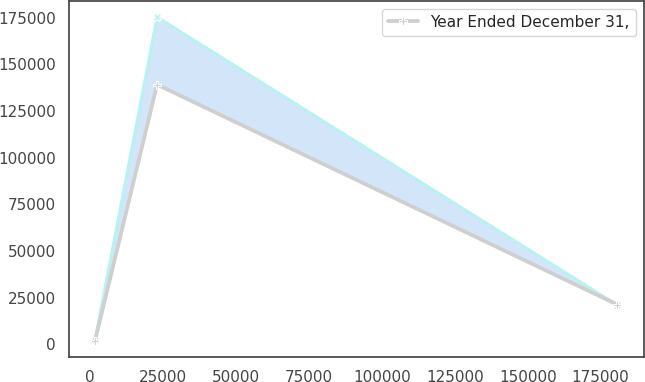Convert chart to OTSL. <chart><loc_0><loc_0><loc_500><loc_500><line_chart><ecel><fcel>Unnamed: 1<fcel>Year Ended December 31,<nl><fcel>1656.86<fcel>2319.66<fcel>2112.16<nl><fcel>22923.5<fcel>175300<fcel>139159<nl><fcel>180744<fcel>21035.8<fcel>21337.8<nl></chart> 